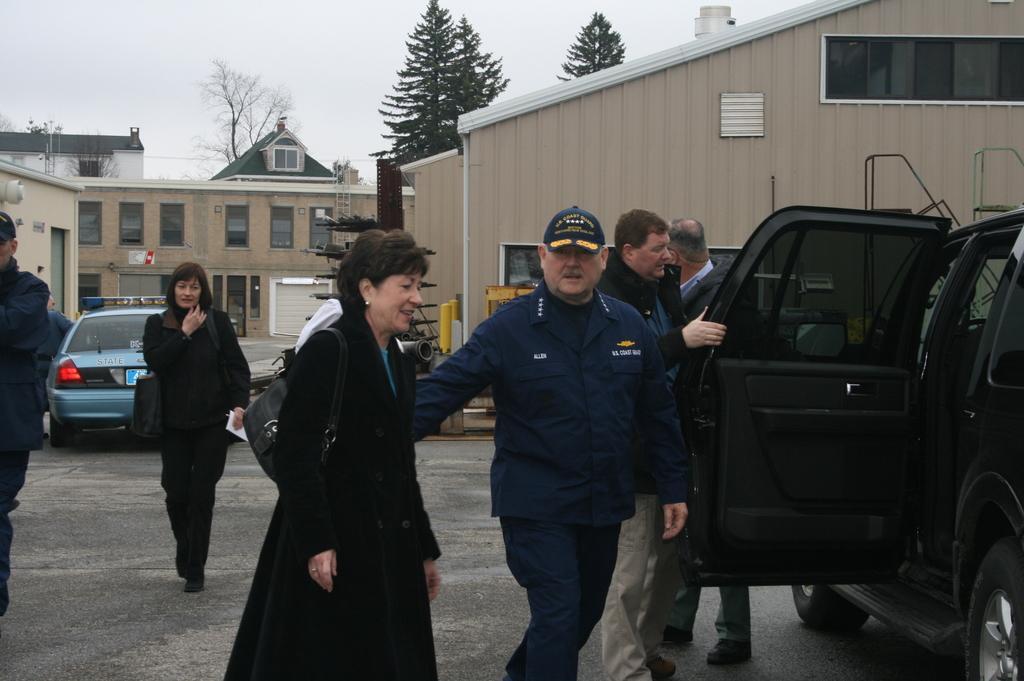How would you summarize this image in a sentence or two? In this picture we can see some people walking, on the right side there is a vehicle, we can see buildings and trees in the background, on the left side there is a car, we can see the sky at the top of the picture. 